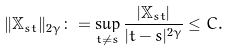<formula> <loc_0><loc_0><loc_500><loc_500>\| \mathbb { X } _ { s t } \| _ { 2 \gamma } \colon = \sup _ { t \neq s } \frac { | \mathbb { X } _ { s t } | } { | t - s | ^ { 2 \gamma } } \leq C .</formula> 